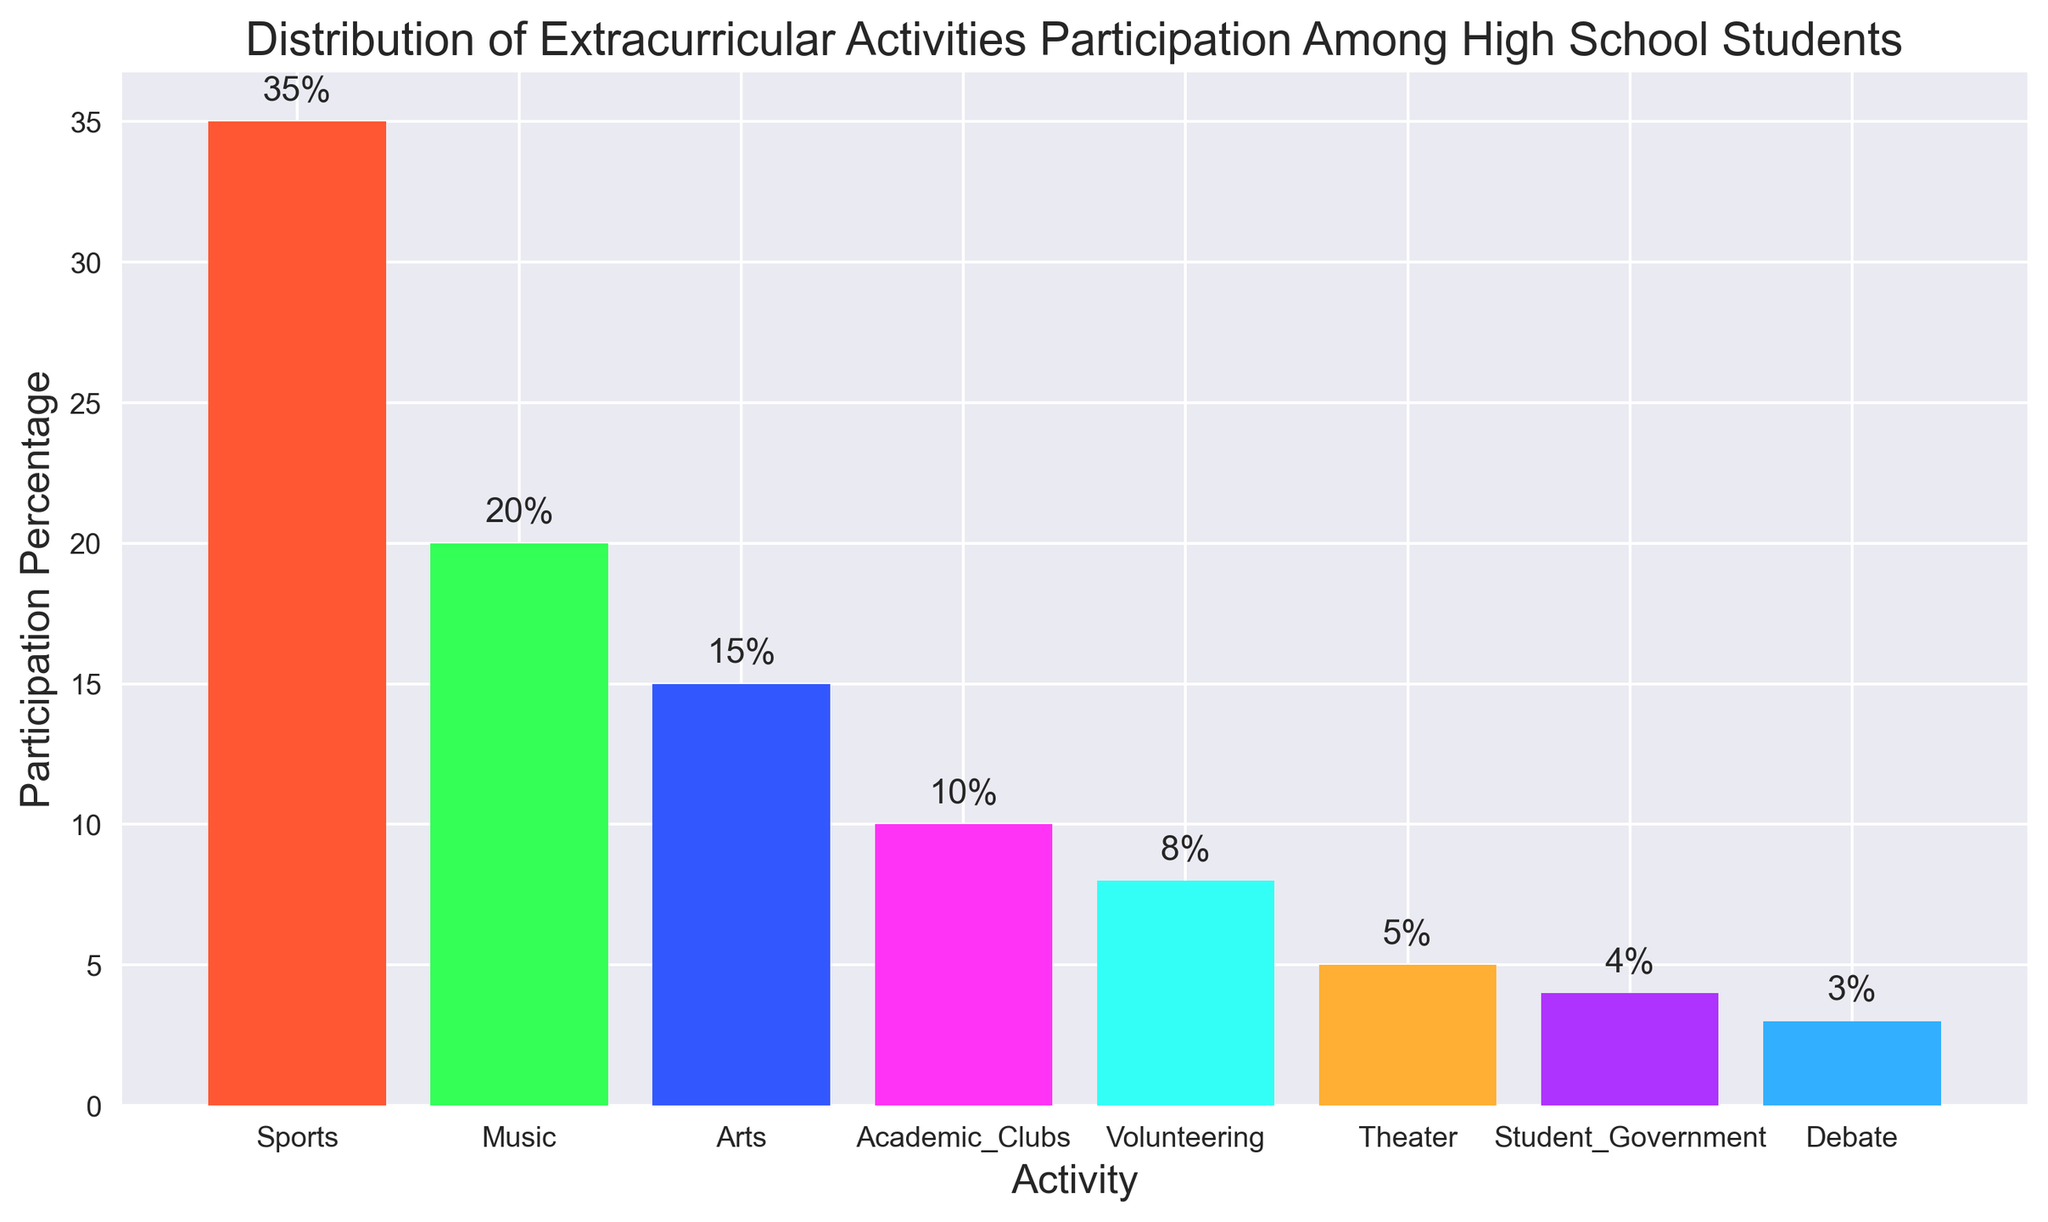What is the activity with the highest participation percentage? By looking at the bar with the greatest height, which represents the highest number, we see that "Sports" has the highest participation percentage at 35%.
Answer: Sports What is the total participation percentage for Music and Arts combined? To find the answer, add the participation percentage of Music (20%) to that of Arts (15%). This results in a total of 20% + 15% = 35%.
Answer: 35% Which activity has the lowest participation percentage? By identifying the bar that is shortest, we find that "Debate" has the lowest participation percentage at 3%.
Answer: Debate How much greater is the participation percentage of Sports compared to Theater? Subtract the participation percentage of Theater (5%) from that of Sports (35%). The difference is 35% - 5% = 30%.
Answer: 30% What is the average participation percentage for Academic Clubs, Volunteering, and Student Government? To find the average, add the percentages of Academic Clubs (10%), Volunteering (8%), and Student Government (4%), then divide by the number of activities. (10% + 8% + 4%) / 3 = 22% / 3 ≈ 7.33%.
Answer: 7.33% Which activity’s participation percentage is closest to the median value of all given percentages? First, list the percentages in ascending order: 3%, 4%, 5%, 8%, 10%, 15%, 20%, 35%. Since there are 8 values, the median is the average of the 4th and 5th values: (8% + 10%) / 2 = 9%. The activity with a participation percentage closest to 9% is Volunteering at 8%.
Answer: Volunteering What is the combined participation percentage of the three least participated activities? Add the percentages of Debate (3%), Student Government (4%), and Theater (5%). The combined percentage is 3% + 4% + 5% = 12%.
Answer: 12% Are there more students participating in Arts or Academic Clubs? By comparing the heights of the bars, we see that Arts has a higher participation percentage (15%) compared to Academic Clubs (10%).
Answer: Arts What is the difference in participation percentage between the most participated and the least participated activity? Subtract the participation percentage of Debate (3%) from that of Sports (35%). The difference is 35% - 3% = 32%.
Answer: 32% Which activities have a participation percentage greater than 10%? By observing the bars taller than the 10% mark, we identify Sports (35%), Music (20%), and Arts (15%) as having participation percentages greater than 10%.
Answer: Sports, Music, Arts 